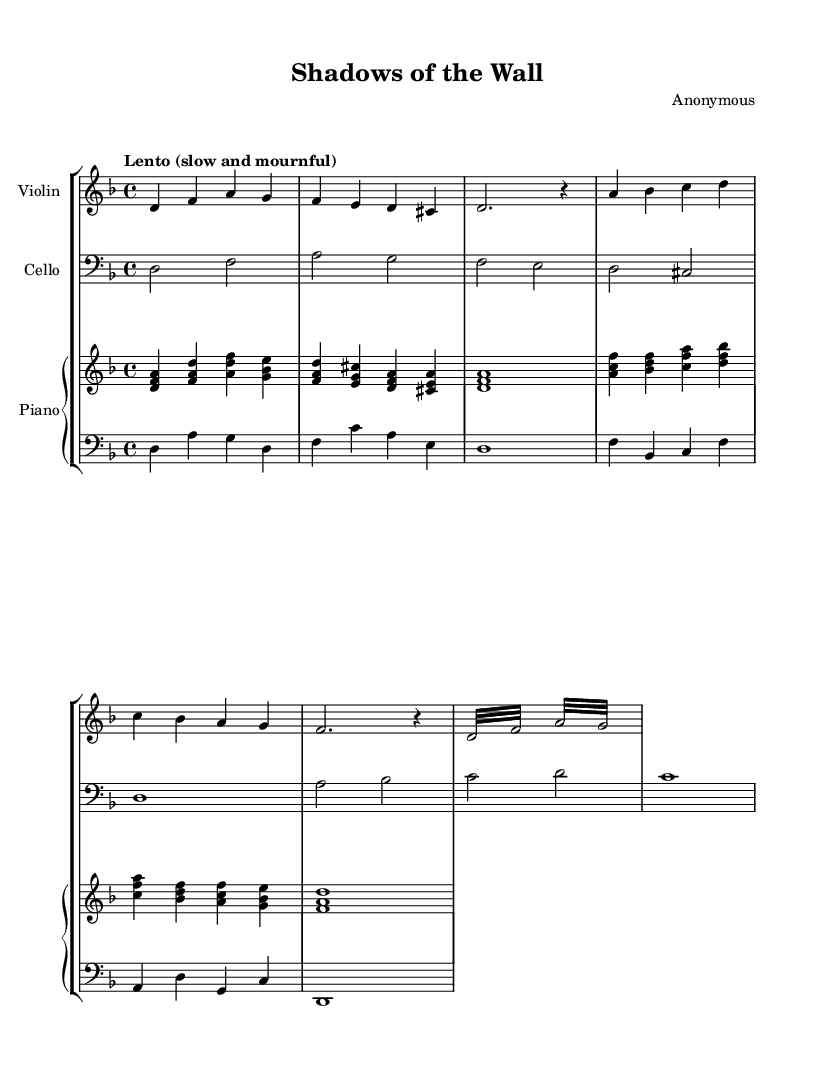What is the key signature of this music? The key signature is indicated by the number of sharps or flats at the beginning of the staff. Here, there is one flat, which corresponds to the key of D minor.
Answer: D minor What is the time signature of this piece? The time signature is found at the beginning of the staff, indicating how many beats are in each measure and what note value gets one beat. Here, it shows 4/4, meaning there are four beats per measure and the quarter note gets one beat.
Answer: 4/4 What is the tempo marking for this composition? The tempo marking is located above the staff and describes how quickly or slowly the piece should be played. The term "Lento" indicates a slow and mournful pace.
Answer: Lento Which instruments are featured in this score? The score includes three different parts labeled for specific instruments: Violin, Cello, and Piano. Each instrument has its own staff for individual parts.
Answer: Violin, Cello, Piano What is the duration of the first note in the violin music? The first note is a quarter note, which can be identified by its filled note head with a stem. It appears in the first bar of the violin part.
Answer: Quarter note How many measures are there in the cello part? The number of measures can be counted by looking at the vertical bar lines that separate them. Counting through the cello music section shows there are four measures.
Answer: Four measures What type of musical effect is indicated by the tremolo in the violin part? The tremolo is represented by repetitive notes played quickly, indicated by the term "tremolo" associated with the notes. This effect adds a sense of urgency and instability, matching the themes of division and isolation.
Answer: Tremolo 